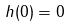Convert formula to latex. <formula><loc_0><loc_0><loc_500><loc_500>h ( 0 ) = 0</formula> 